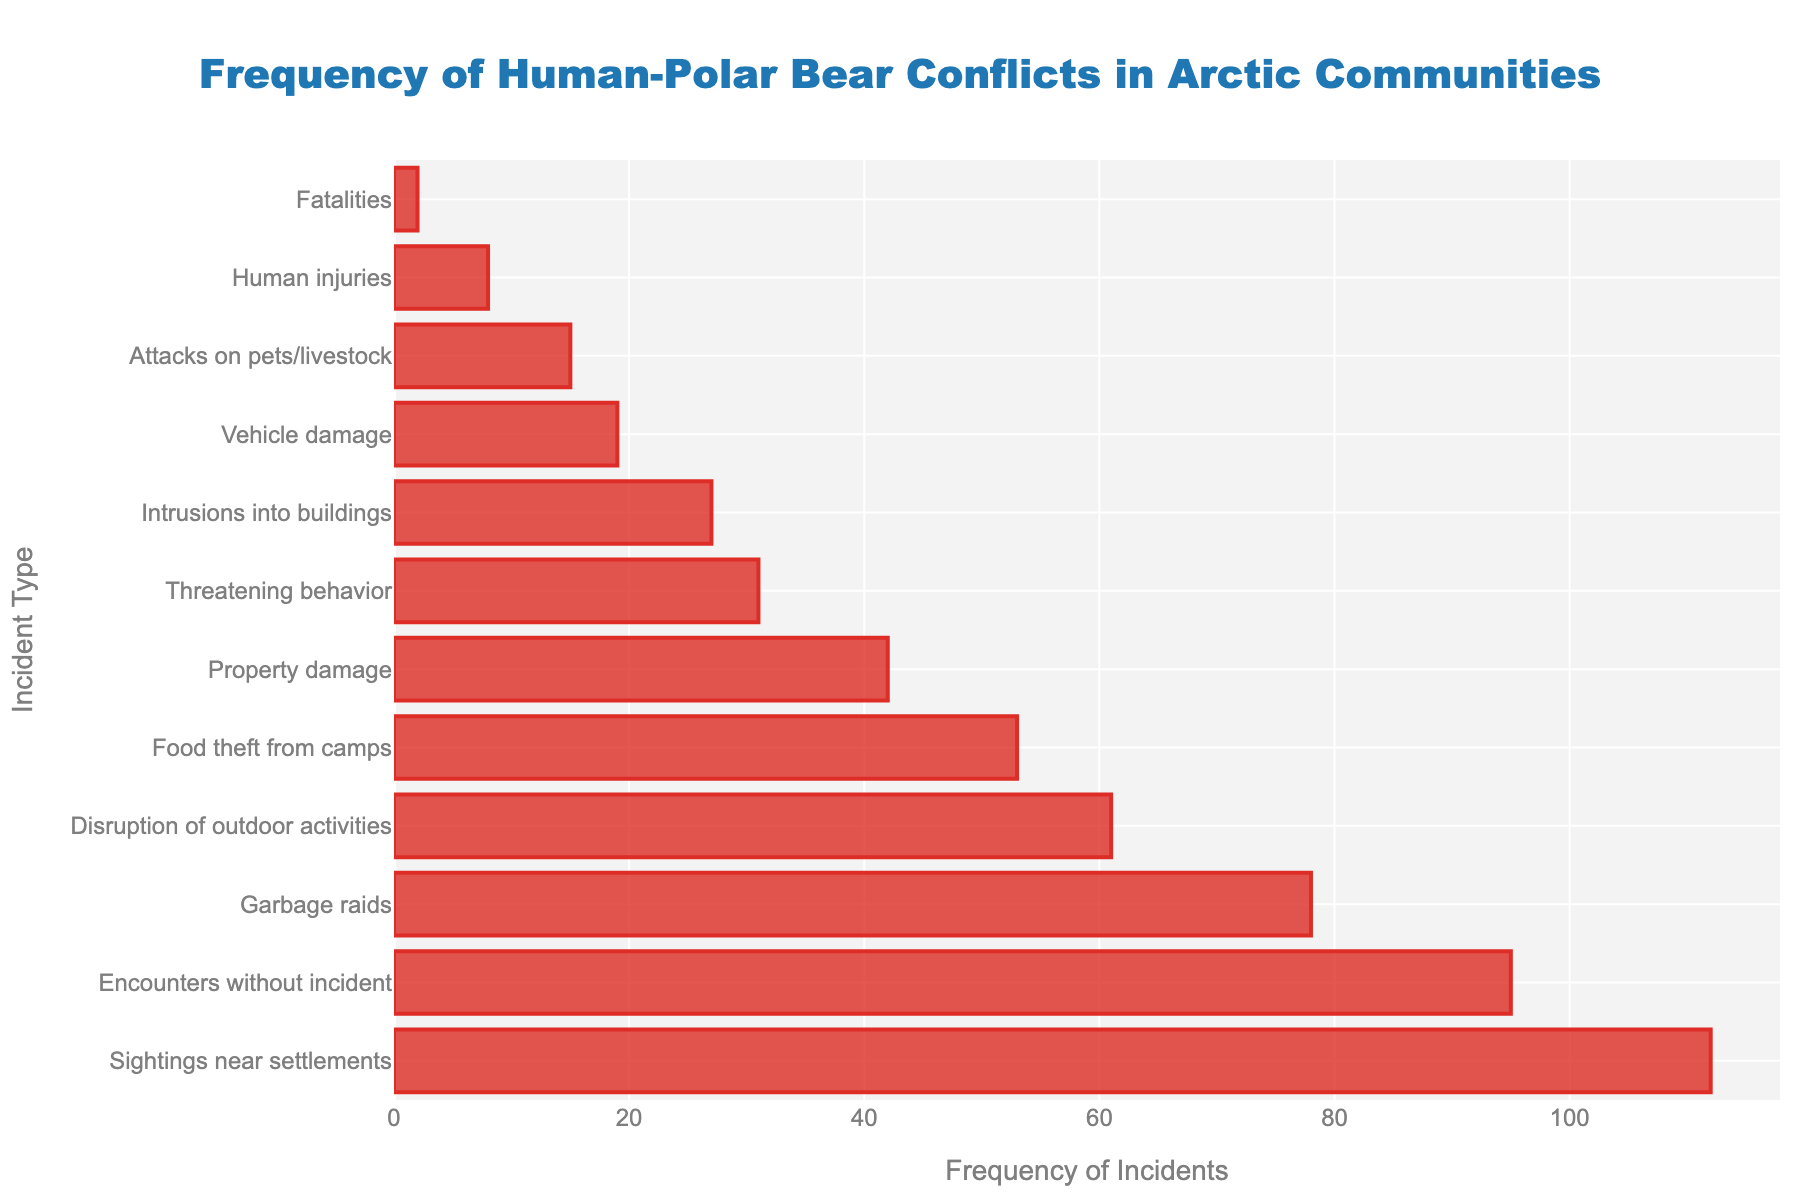What is the most frequent type of human-polar bear conflict? The highest bar represents the most frequent type of conflict. In this case, "Sightings near settlements" is the tallest bar, indicating it is the most frequent.
Answer: Sightings near settlements Which incident type has the fewest occurrences? The shortest bar represents the conflict type with the fewest occurrences. "Fatalities" is the shortest bar, indicating it occurs the least.
Answer: Fatalities What is the combined frequency of property damage, garbage raids, and human injuries? Sum the frequencies of "Property damage" (42), "Garbage raids" (78), and "Human injuries" (8). Thus, 42 + 78 + 8 = 128.
Answer: 128 Which is more frequent, garbage raids or vehicle damage? Compare the heights of the bars for "Garbage raids" (78) and "Vehicle damage" (19). Garbage raids have a significantly higher frequency than vehicle damage.
Answer: Garbage raids Does the frequency of food theft from camps exceed property damage? Compare the bars for "Food theft from camps" (53) and "Property damage" (42). The frequency of food theft from camps is higher than that of property damage.
Answer: Yes How much higher is the frequency of sightings near settlements compared to threatening behavior? Subtract the frequency of "Threatening behavior" (31) from the frequency of "Sightings near settlements" (112). Thus, 112 - 31 = 81.
Answer: 81 What is the approximate middle value of all incident frequencies (median)? Arrange the frequencies in ascending order: 2, 8, 15, 19, 27, 31, 42, 53, 61, 78, 95, 112. The median is the average of the 6th and 7th values: (31 + 42) / 2 = 36.5.
Answer: 36.5 Are intrusions into buildings more frequent than attacks on pets/livestock? Compare the bars for "Intrusions into buildings" (27) and "Attacks on pets/livestock" (15). Intrusions into buildings have a higher frequency than attacks on pets/livestock.
Answer: Yes Which three incident types have the highest frequencies? Identify the three tallest bars. They represent "Sightings near settlements" (112), "Encounters without incident" (95), and "Garbage raids" (78).
Answer: Sightings near settlements, Encounters without incident, Garbage raids 